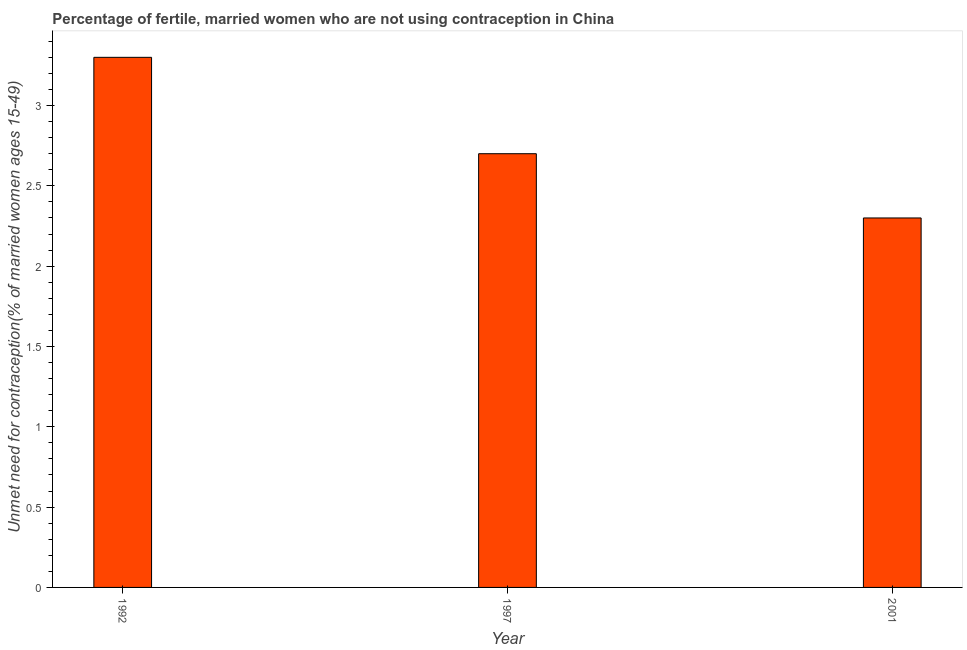What is the title of the graph?
Provide a succinct answer. Percentage of fertile, married women who are not using contraception in China. What is the label or title of the Y-axis?
Offer a very short reply.  Unmet need for contraception(% of married women ages 15-49). What is the number of married women who are not using contraception in 1997?
Make the answer very short. 2.7. Across all years, what is the minimum number of married women who are not using contraception?
Keep it short and to the point. 2.3. What is the sum of the number of married women who are not using contraception?
Your answer should be very brief. 8.3. What is the difference between the number of married women who are not using contraception in 1992 and 1997?
Provide a short and direct response. 0.6. What is the average number of married women who are not using contraception per year?
Keep it short and to the point. 2.77. What is the median number of married women who are not using contraception?
Your answer should be very brief. 2.7. In how many years, is the number of married women who are not using contraception greater than 1.4 %?
Keep it short and to the point. 3. Do a majority of the years between 1992 and 1997 (inclusive) have number of married women who are not using contraception greater than 2.7 %?
Provide a short and direct response. No. What is the ratio of the number of married women who are not using contraception in 1997 to that in 2001?
Offer a very short reply. 1.17. Is the number of married women who are not using contraception in 1992 less than that in 1997?
Your answer should be compact. No. Is the difference between the number of married women who are not using contraception in 1997 and 2001 greater than the difference between any two years?
Provide a short and direct response. No. What is the difference between the highest and the second highest number of married women who are not using contraception?
Offer a terse response. 0.6. Is the sum of the number of married women who are not using contraception in 1997 and 2001 greater than the maximum number of married women who are not using contraception across all years?
Provide a short and direct response. Yes. In how many years, is the number of married women who are not using contraception greater than the average number of married women who are not using contraception taken over all years?
Provide a short and direct response. 1. How many bars are there?
Provide a succinct answer. 3. Are all the bars in the graph horizontal?
Provide a short and direct response. No. How many years are there in the graph?
Provide a succinct answer. 3. Are the values on the major ticks of Y-axis written in scientific E-notation?
Offer a terse response. No. What is the  Unmet need for contraception(% of married women ages 15-49) in 1997?
Offer a terse response. 2.7. What is the  Unmet need for contraception(% of married women ages 15-49) of 2001?
Provide a short and direct response. 2.3. What is the difference between the  Unmet need for contraception(% of married women ages 15-49) in 1992 and 1997?
Your response must be concise. 0.6. What is the ratio of the  Unmet need for contraception(% of married women ages 15-49) in 1992 to that in 1997?
Keep it short and to the point. 1.22. What is the ratio of the  Unmet need for contraception(% of married women ages 15-49) in 1992 to that in 2001?
Your answer should be very brief. 1.44. What is the ratio of the  Unmet need for contraception(% of married women ages 15-49) in 1997 to that in 2001?
Make the answer very short. 1.17. 